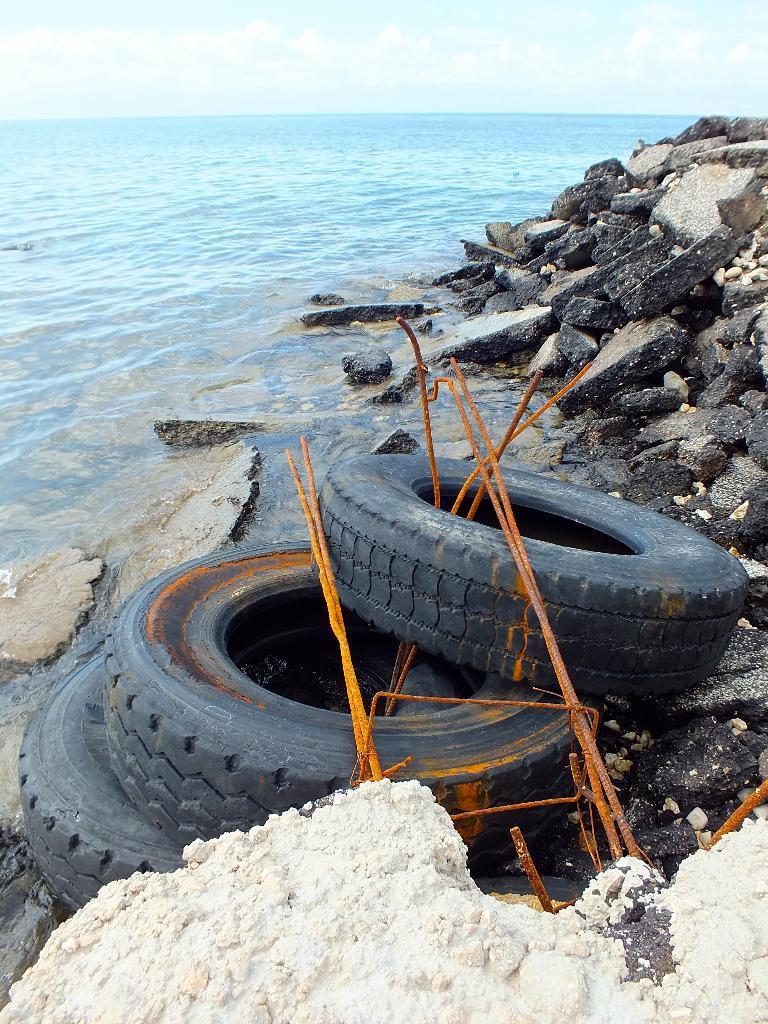How would you summarize this image in a sentence or two? This picture is clicked outside. In the foreground we can see the tires of a vehicle and we can see the metal rods and some other objects and we can see the rocks. In the background there is a sky and a water body. 